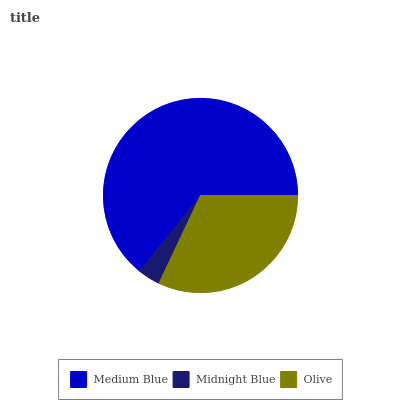Is Midnight Blue the minimum?
Answer yes or no. Yes. Is Medium Blue the maximum?
Answer yes or no. Yes. Is Olive the minimum?
Answer yes or no. No. Is Olive the maximum?
Answer yes or no. No. Is Olive greater than Midnight Blue?
Answer yes or no. Yes. Is Midnight Blue less than Olive?
Answer yes or no. Yes. Is Midnight Blue greater than Olive?
Answer yes or no. No. Is Olive less than Midnight Blue?
Answer yes or no. No. Is Olive the high median?
Answer yes or no. Yes. Is Olive the low median?
Answer yes or no. Yes. Is Midnight Blue the high median?
Answer yes or no. No. Is Midnight Blue the low median?
Answer yes or no. No. 